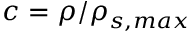<formula> <loc_0><loc_0><loc_500><loc_500>c = \rho / \rho _ { s , \max }</formula> 